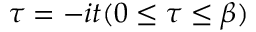<formula> <loc_0><loc_0><loc_500><loc_500>\tau = - i t ( 0 \leq \tau \leq \beta )</formula> 